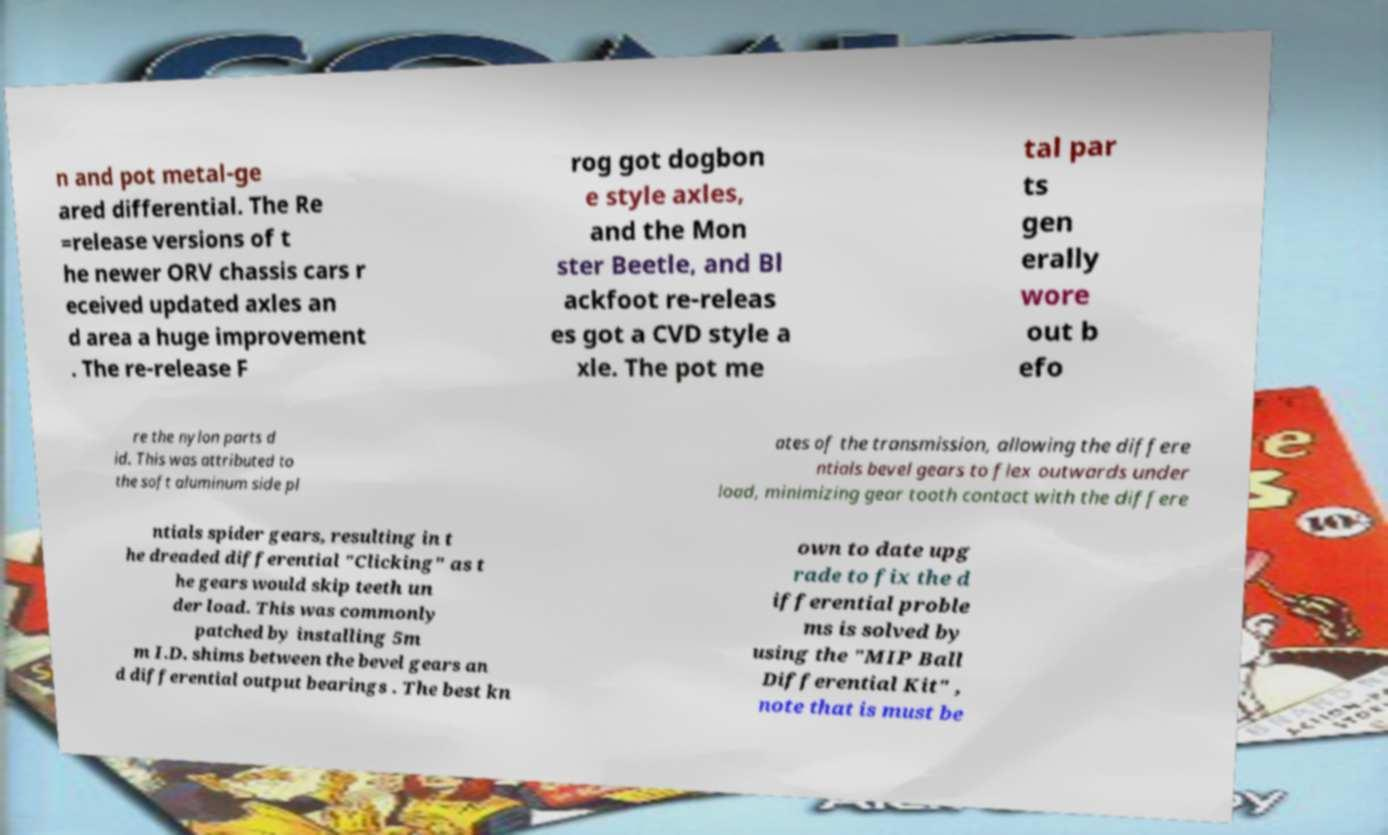Can you accurately transcribe the text from the provided image for me? n and pot metal-ge ared differential. The Re =release versions of t he newer ORV chassis cars r eceived updated axles an d area a huge improvement . The re-release F rog got dogbon e style axles, and the Mon ster Beetle, and Bl ackfoot re-releas es got a CVD style a xle. The pot me tal par ts gen erally wore out b efo re the nylon parts d id. This was attributed to the soft aluminum side pl ates of the transmission, allowing the differe ntials bevel gears to flex outwards under load, minimizing gear tooth contact with the differe ntials spider gears, resulting in t he dreaded differential "Clicking" as t he gears would skip teeth un der load. This was commonly patched by installing 5m m I.D. shims between the bevel gears an d differential output bearings . The best kn own to date upg rade to fix the d ifferential proble ms is solved by using the "MIP Ball Differential Kit" , note that is must be 